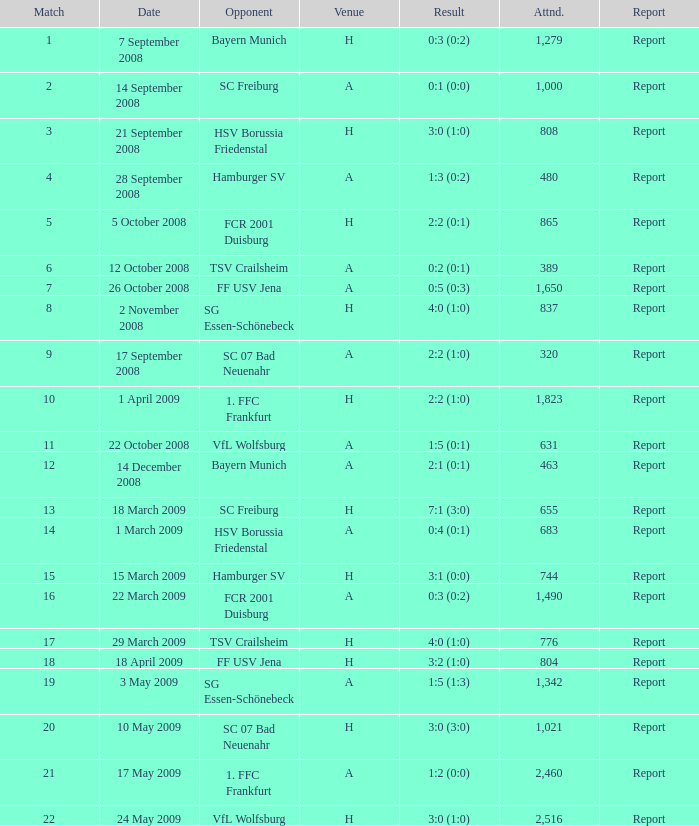What is the contest number that yielded a score of 0:5 (0:3)? 1.0. 